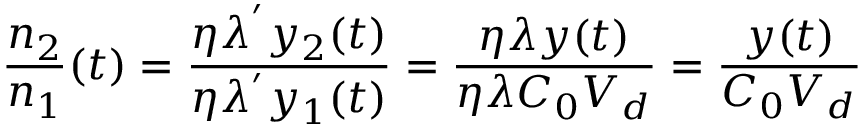<formula> <loc_0><loc_0><loc_500><loc_500>\frac { n _ { 2 } } { n _ { 1 } } ( t ) = \frac { \eta \lambda ^ { ^ { \prime } } y _ { 2 } ( t ) } { \eta \lambda ^ { ^ { \prime } } y _ { 1 } ( t ) } = \frac { \eta \lambda y ( t ) } { \eta \lambda C _ { 0 } V _ { d } } = \frac { y ( t ) } { C _ { 0 } V _ { d } }</formula> 